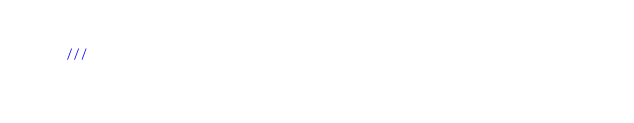Convert code to text. <code><loc_0><loc_0><loc_500><loc_500><_Rust_>
    ///</code> 